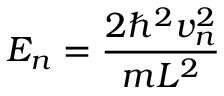Convert formula to latex. <formula><loc_0><loc_0><loc_500><loc_500>E _ { n } = { \frac { 2 \hbar { ^ } { 2 } v _ { n } ^ { 2 } } { m L ^ { 2 } } }</formula> 